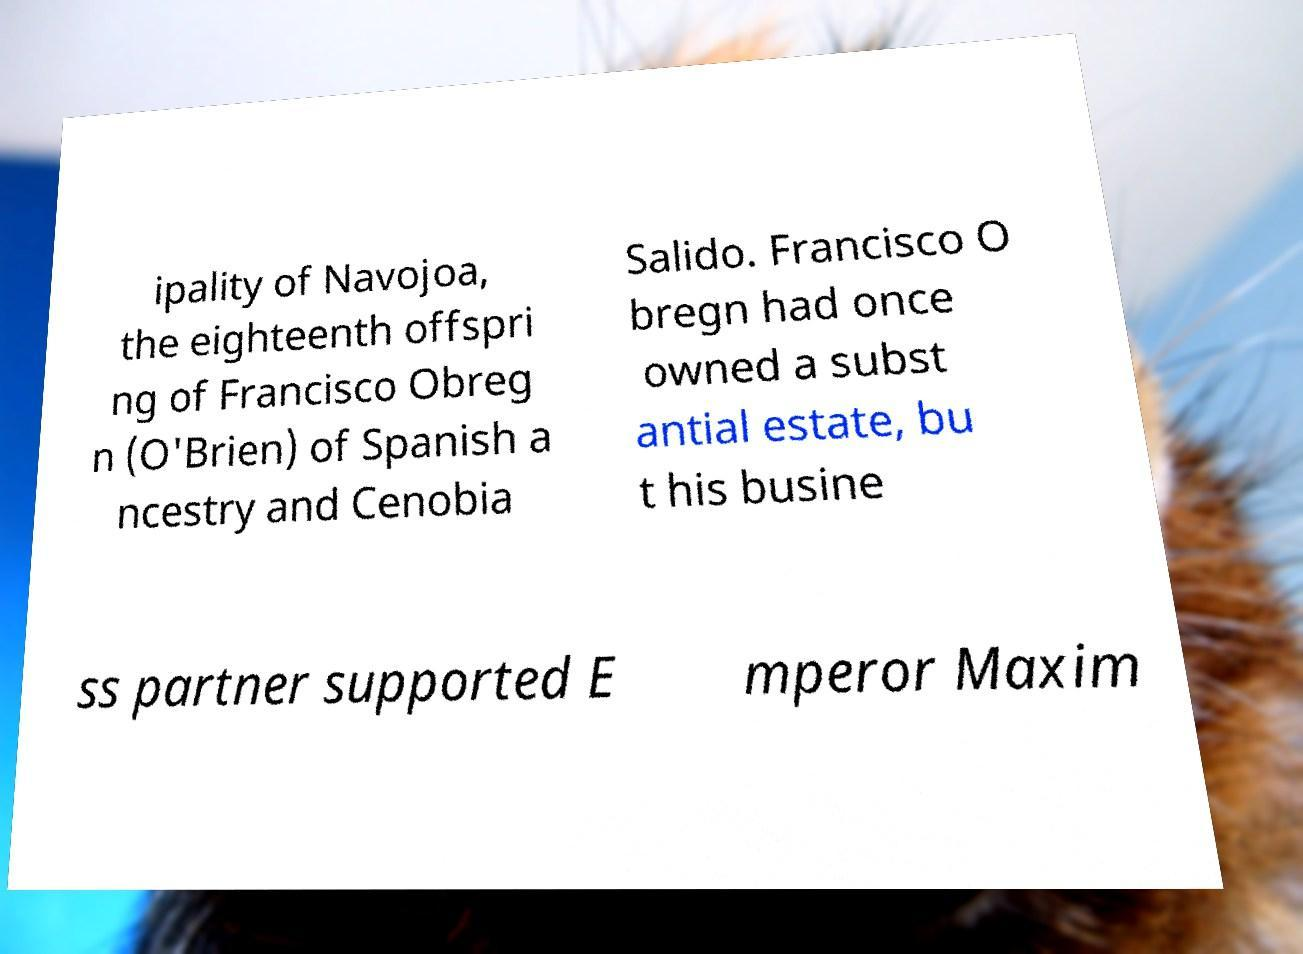Please identify and transcribe the text found in this image. ipality of Navojoa, the eighteenth offspri ng of Francisco Obreg n (O'Brien) of Spanish a ncestry and Cenobia Salido. Francisco O bregn had once owned a subst antial estate, bu t his busine ss partner supported E mperor Maxim 